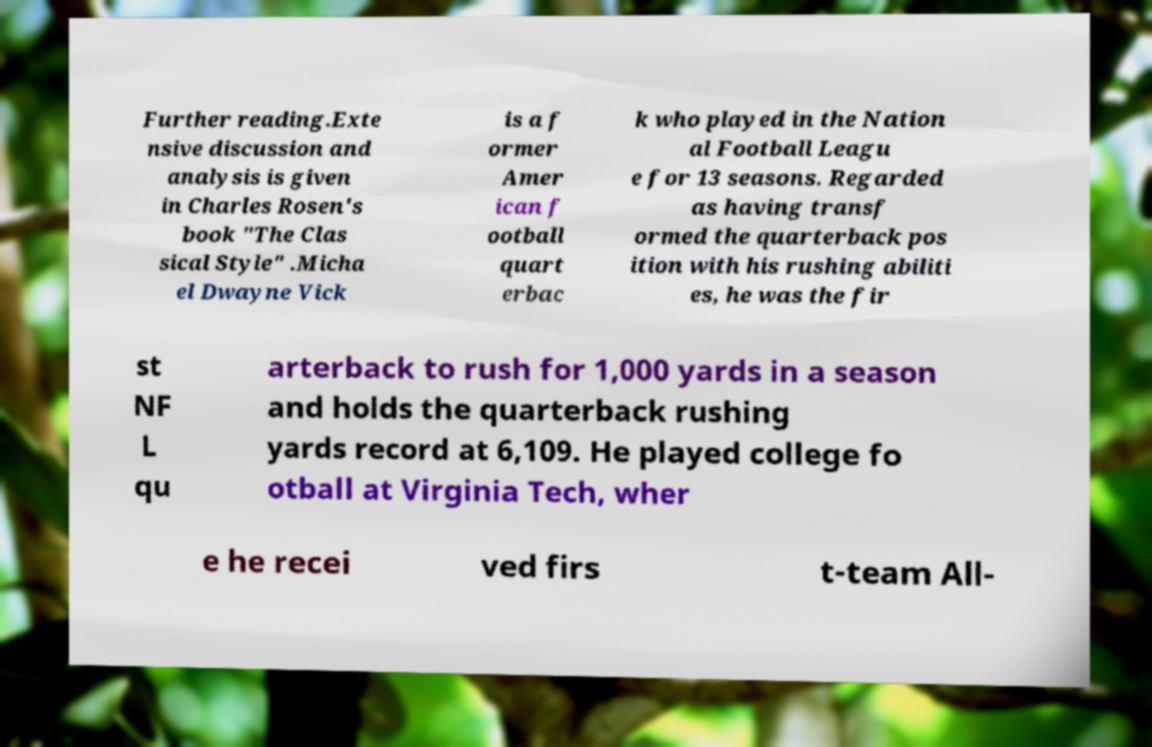Could you extract and type out the text from this image? Further reading.Exte nsive discussion and analysis is given in Charles Rosen's book "The Clas sical Style" .Micha el Dwayne Vick is a f ormer Amer ican f ootball quart erbac k who played in the Nation al Football Leagu e for 13 seasons. Regarded as having transf ormed the quarterback pos ition with his rushing abiliti es, he was the fir st NF L qu arterback to rush for 1,000 yards in a season and holds the quarterback rushing yards record at 6,109. He played college fo otball at Virginia Tech, wher e he recei ved firs t-team All- 